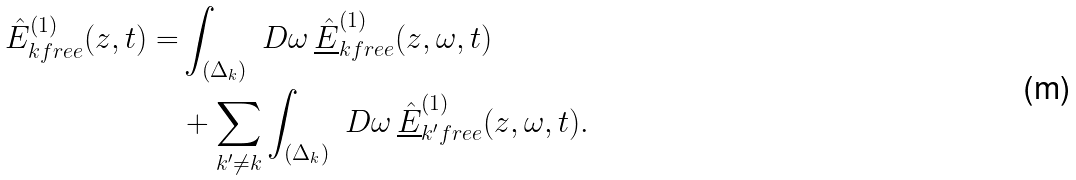Convert formula to latex. <formula><loc_0><loc_0><loc_500><loc_500>\hat { E } _ { k f r e e } ^ { ( 1 ) } ( z , t ) = & \int _ { ( \Delta _ { k } ) } \ D \omega \, \underline { \hat { E } } _ { k f r e e } ^ { ( 1 ) } ( z , \omega , t ) \\ & + \sum _ { k ^ { \prime } \neq k } \int _ { ( \Delta _ { k } ) } \ D \omega \, \underline { \hat { E } } _ { k ^ { \prime } f r e e } ^ { ( 1 ) } ( z , \omega , t ) .</formula> 